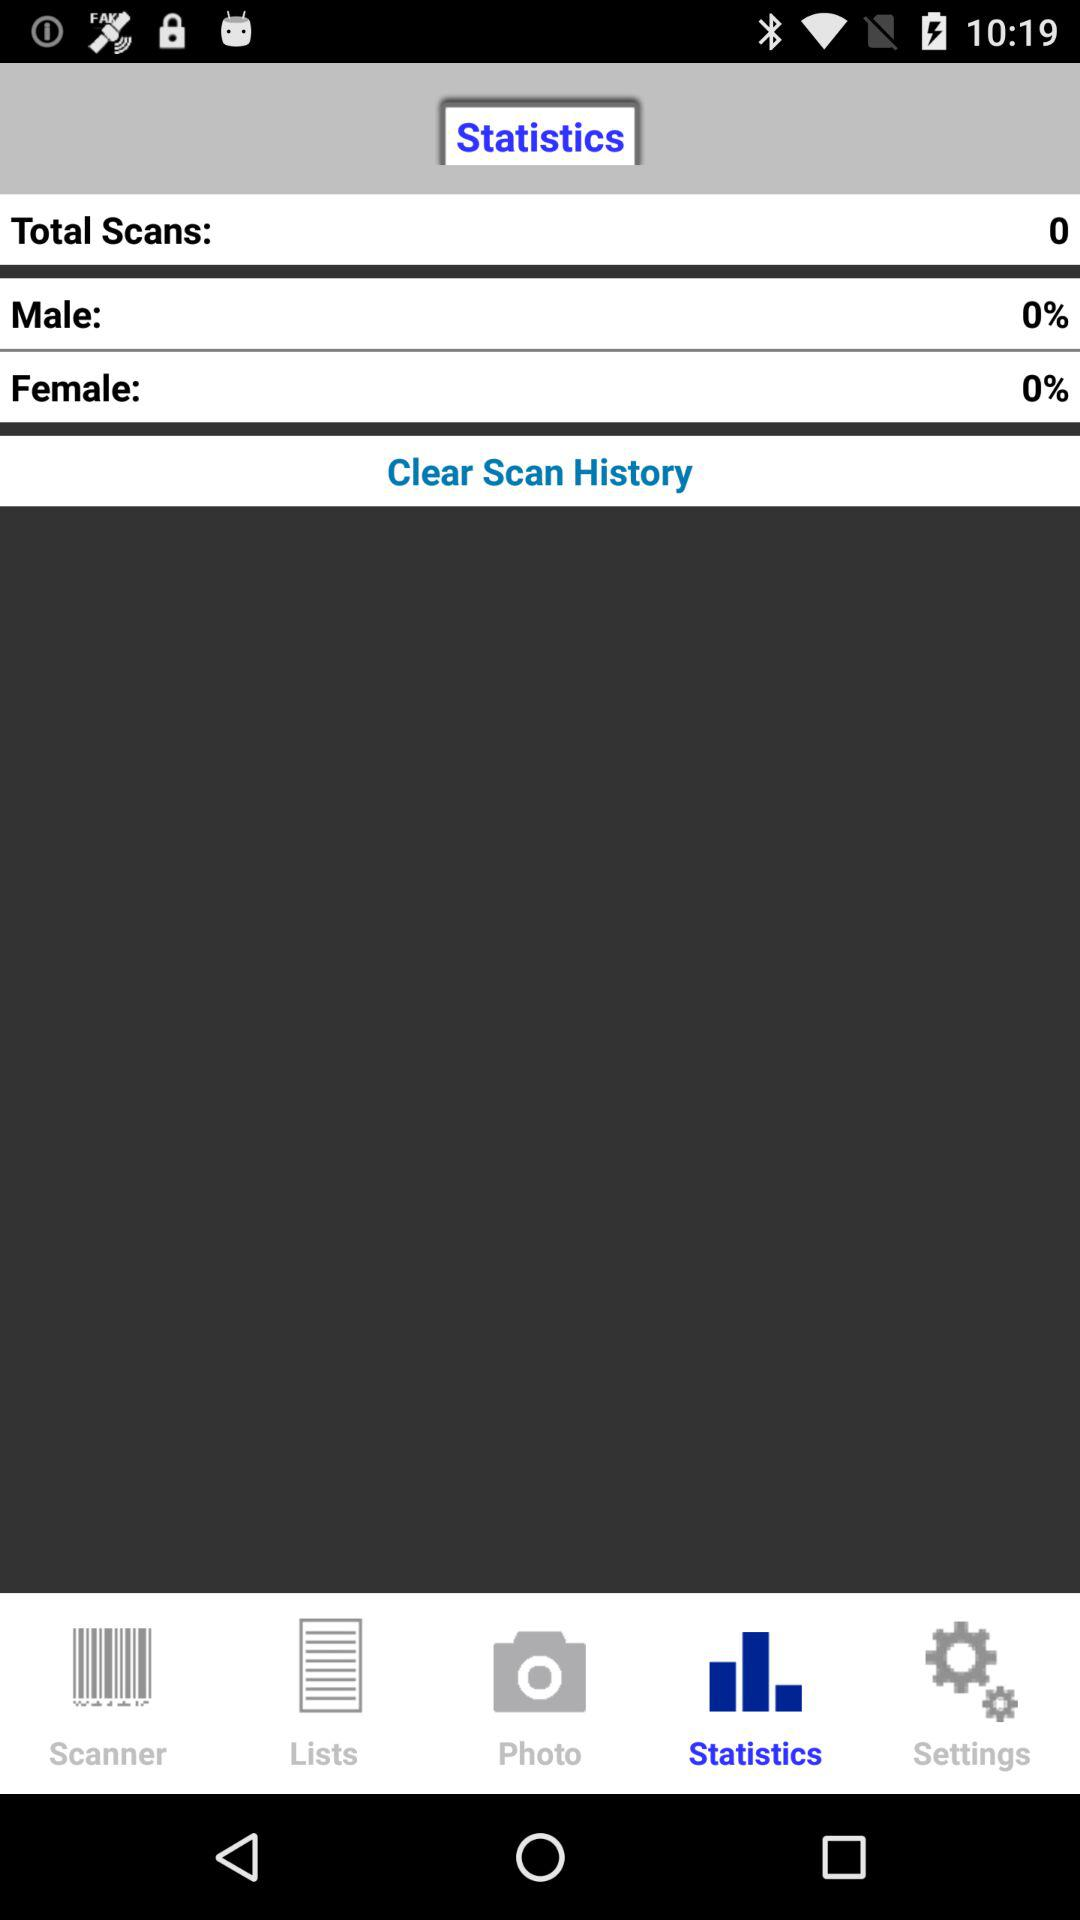What is the total number of scans? The total number of scans is 0. 